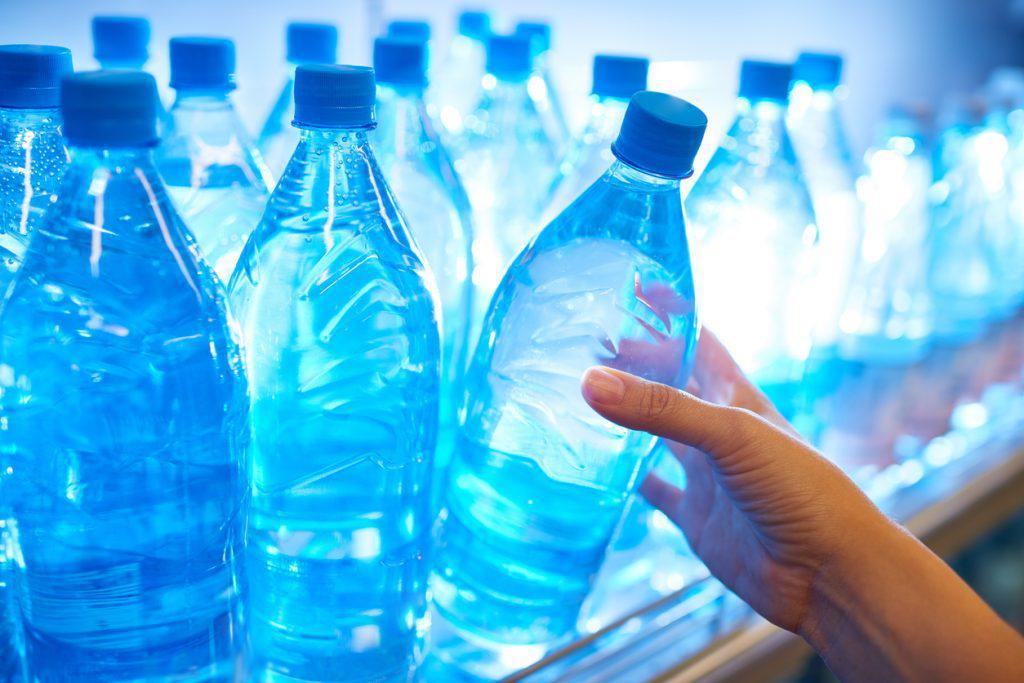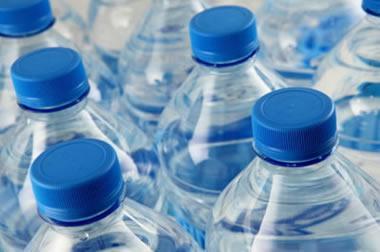The first image is the image on the left, the second image is the image on the right. Considering the images on both sides, is "All bottles of water have blue plastic caps." valid? Answer yes or no. Yes. 